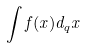Convert formula to latex. <formula><loc_0><loc_0><loc_500><loc_500>\int f ( x ) d _ { q } x</formula> 